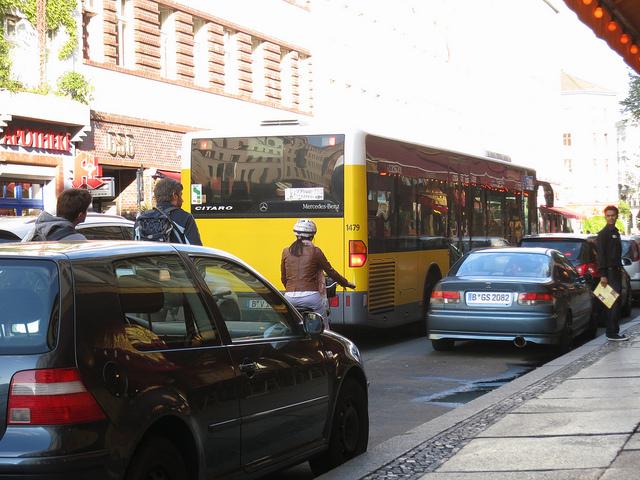Is it safe for the cyclists on this road? Safety can be subjective, but based on the image, the cyclists seem to be riding confidently amidst the traffic, indicating that the road conditions may be suitable for cycling. However, there are no dedicated bike lanes visible, so cyclists must share the road with larger vehicles like buses and cars, which can pose safety challenges without proper awareness and caution from all parties. 